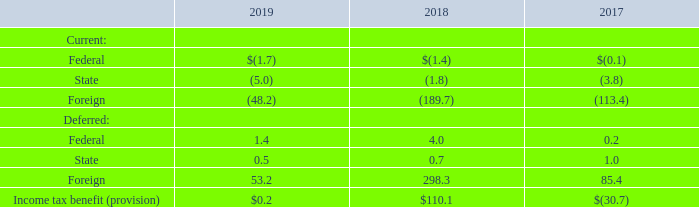AMERICAN TOWER CORPORATION AND SUBSIDIARIES NOTES TO CONSOLIDATED FINANCIAL STATEMENTS (Tabular amounts in millions, unless otherwise disclosed)
13. INCOME TAXES
Beginning in the taxable year ended December 31, 2012, the Company has filed, and intends to continue to file, U.S. federal income tax returns as a REIT, and its domestic TRSs filed, and intend to continue to file, separate tax returns as required. The Company also files tax returns in various states and countries. The Company’s state tax returns reflect different combinations of the Company’s subsidiaries and are dependent on the connection each subsidiary has with a particular state and form of organization. The following information pertains to the Company’s income taxes on a consolidated basis.
The income tax provision from continuing operations consisted of the following:
The effective tax rate (“ETR”) on income from continuing operations for the years ended December 31, 2019, 2018 and 2017 differs from the federal statutory rate primarily due to the Company’s qualification for taxation as a REIT, as well as adjustments for state and foreign items. As a REIT, the Company may deduct earnings distributed to stockholders against the income generated by its REIT operations. In addition, the Company is able to offset certain income by utilizing its NOLs, subject to specified limitations.
What was the deferred Federal Income tax benefit (provision) in 2017?
Answer scale should be: million. 0.2. What do the company's state tax returns reflect? Different combinations of the company’s subsidiaries and are dependent on the connection each subsidiary has with a particular state and form of organization. What was the deferred Foreign income tax provision in 2019?
Answer scale should be: million. 53.2. How many of the deferred Income tax benefit (provision) were above $50 million in 2017? Foreign
Answer: 1. How many of the current Income tax benefit (provision) were above $(4 million) in 2019? Foreign##State
Answer: 2. What was the percentage change in Income tax benefit (provision) between 2018 and 2019?
Answer scale should be: percent. ($0.2-$110.1)/$110.1
Answer: -99.82. 